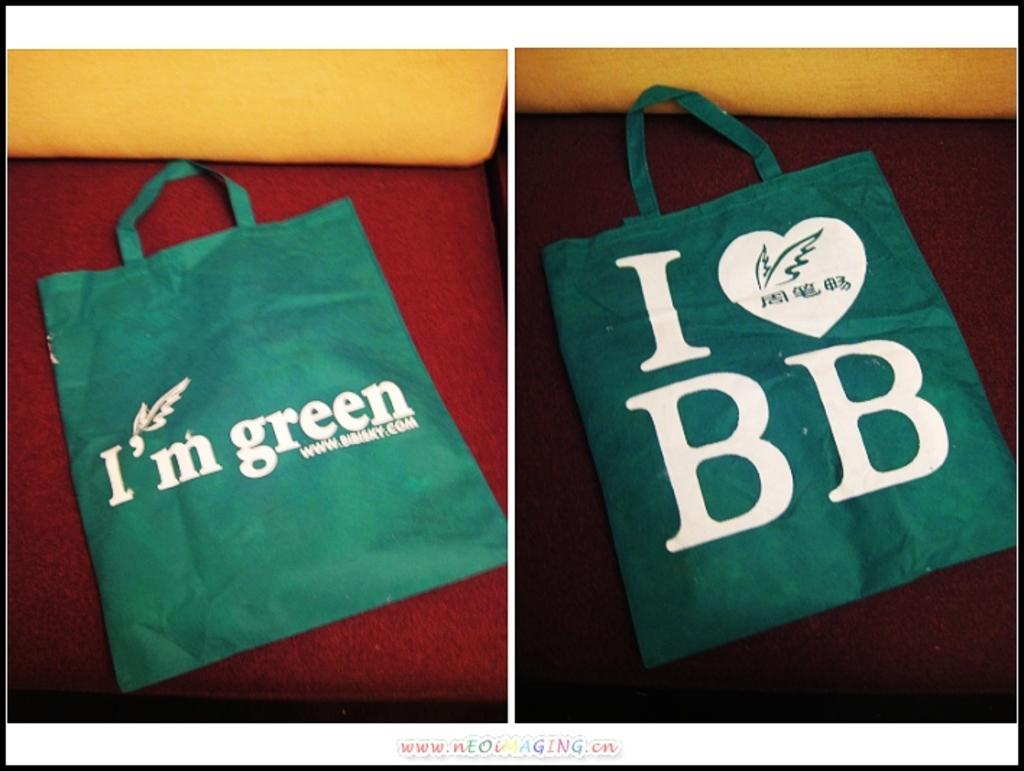How many bags are visible in the image? There are two bags in the image. Where are the bags located? The bags are on a sofa. What type of yarn is being used to create a pattern on the sofa? There is no yarn or pattern visible on the sofa in the image. 